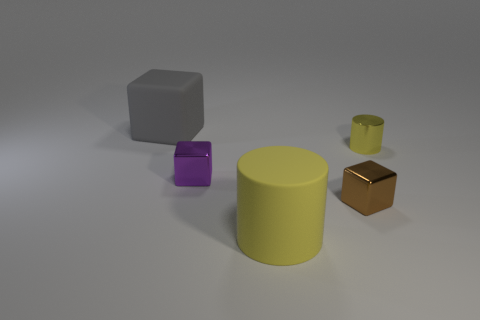What can you infer about the size relationships among the objects shown? The objects vary in size, with the yellow cylinder being the largest and the small brown cube appearing to be the smallest, which might imply a discussion on perspective or scale. 